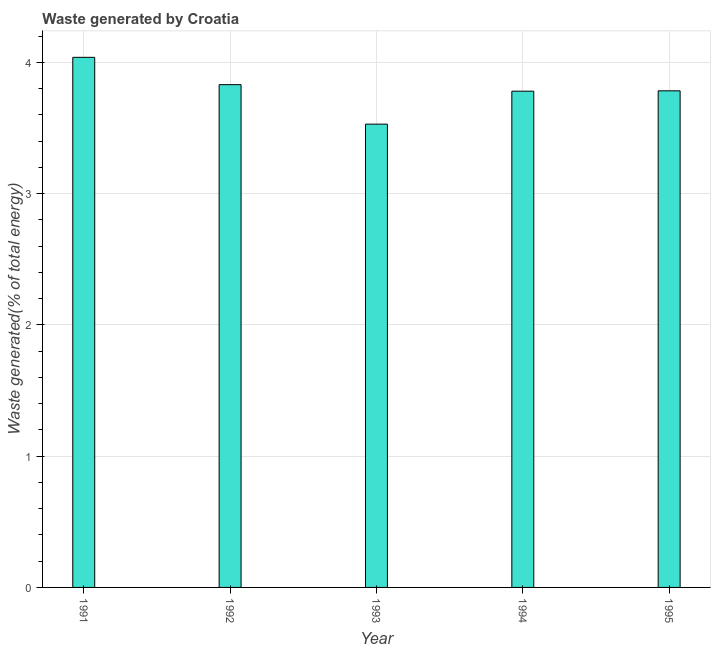Does the graph contain any zero values?
Offer a very short reply. No. What is the title of the graph?
Offer a terse response. Waste generated by Croatia. What is the label or title of the Y-axis?
Ensure brevity in your answer.  Waste generated(% of total energy). What is the amount of waste generated in 1995?
Provide a short and direct response. 3.78. Across all years, what is the maximum amount of waste generated?
Ensure brevity in your answer.  4.04. Across all years, what is the minimum amount of waste generated?
Your response must be concise. 3.53. In which year was the amount of waste generated maximum?
Ensure brevity in your answer.  1991. In which year was the amount of waste generated minimum?
Your answer should be compact. 1993. What is the sum of the amount of waste generated?
Offer a very short reply. 18.96. What is the difference between the amount of waste generated in 1992 and 1993?
Offer a very short reply. 0.3. What is the average amount of waste generated per year?
Your response must be concise. 3.79. What is the median amount of waste generated?
Your answer should be very brief. 3.78. What is the ratio of the amount of waste generated in 1991 to that in 1992?
Your answer should be compact. 1.05. Is the amount of waste generated in 1992 less than that in 1995?
Make the answer very short. No. What is the difference between the highest and the second highest amount of waste generated?
Provide a short and direct response. 0.21. Is the sum of the amount of waste generated in 1991 and 1992 greater than the maximum amount of waste generated across all years?
Offer a very short reply. Yes. What is the difference between the highest and the lowest amount of waste generated?
Provide a short and direct response. 0.51. Are all the bars in the graph horizontal?
Offer a terse response. No. What is the difference between two consecutive major ticks on the Y-axis?
Make the answer very short. 1. Are the values on the major ticks of Y-axis written in scientific E-notation?
Offer a terse response. No. What is the Waste generated(% of total energy) of 1991?
Your answer should be compact. 4.04. What is the Waste generated(% of total energy) in 1992?
Provide a succinct answer. 3.83. What is the Waste generated(% of total energy) in 1993?
Your response must be concise. 3.53. What is the Waste generated(% of total energy) in 1994?
Provide a succinct answer. 3.78. What is the Waste generated(% of total energy) in 1995?
Ensure brevity in your answer.  3.78. What is the difference between the Waste generated(% of total energy) in 1991 and 1992?
Your answer should be very brief. 0.21. What is the difference between the Waste generated(% of total energy) in 1991 and 1993?
Offer a very short reply. 0.51. What is the difference between the Waste generated(% of total energy) in 1991 and 1994?
Your response must be concise. 0.26. What is the difference between the Waste generated(% of total energy) in 1991 and 1995?
Provide a short and direct response. 0.26. What is the difference between the Waste generated(% of total energy) in 1992 and 1993?
Your answer should be compact. 0.3. What is the difference between the Waste generated(% of total energy) in 1992 and 1994?
Your answer should be compact. 0.05. What is the difference between the Waste generated(% of total energy) in 1992 and 1995?
Your answer should be very brief. 0.05. What is the difference between the Waste generated(% of total energy) in 1993 and 1994?
Ensure brevity in your answer.  -0.25. What is the difference between the Waste generated(% of total energy) in 1993 and 1995?
Provide a short and direct response. -0.25. What is the difference between the Waste generated(% of total energy) in 1994 and 1995?
Make the answer very short. -0. What is the ratio of the Waste generated(% of total energy) in 1991 to that in 1992?
Provide a succinct answer. 1.05. What is the ratio of the Waste generated(% of total energy) in 1991 to that in 1993?
Provide a short and direct response. 1.14. What is the ratio of the Waste generated(% of total energy) in 1991 to that in 1994?
Provide a succinct answer. 1.07. What is the ratio of the Waste generated(% of total energy) in 1991 to that in 1995?
Provide a succinct answer. 1.07. What is the ratio of the Waste generated(% of total energy) in 1992 to that in 1993?
Offer a very short reply. 1.08. What is the ratio of the Waste generated(% of total energy) in 1992 to that in 1994?
Give a very brief answer. 1.01. What is the ratio of the Waste generated(% of total energy) in 1993 to that in 1994?
Give a very brief answer. 0.93. What is the ratio of the Waste generated(% of total energy) in 1993 to that in 1995?
Your response must be concise. 0.93. What is the ratio of the Waste generated(% of total energy) in 1994 to that in 1995?
Provide a succinct answer. 1. 